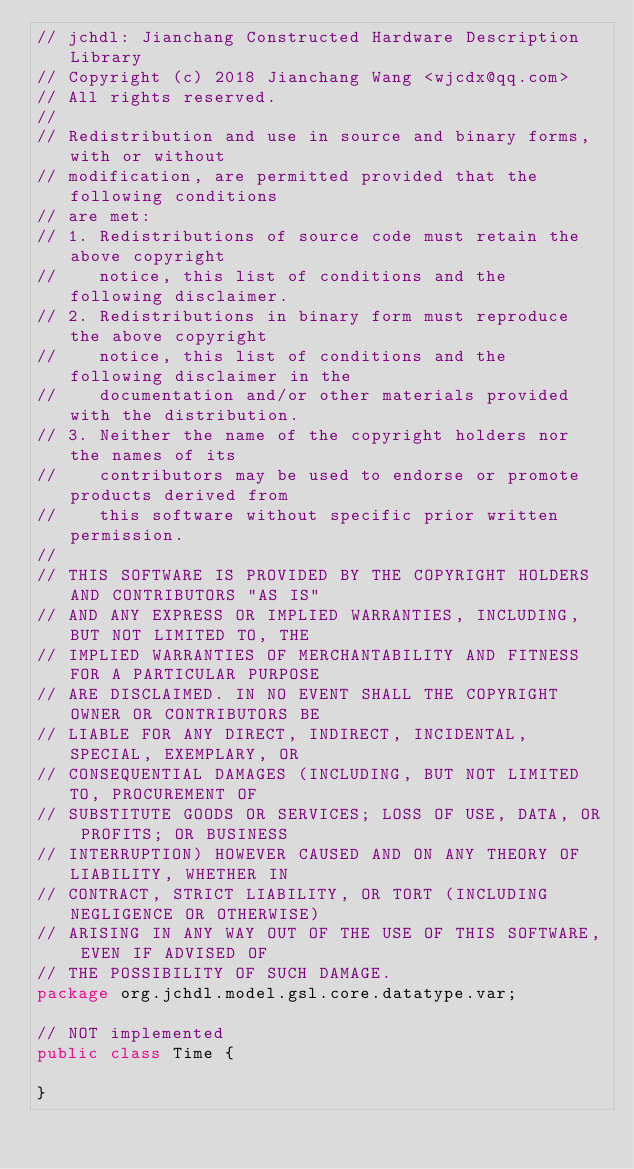<code> <loc_0><loc_0><loc_500><loc_500><_Java_>// jchdl: Jianchang Constructed Hardware Description Library
// Copyright (c) 2018 Jianchang Wang <wjcdx@qq.com>
// All rights reserved.
//
// Redistribution and use in source and binary forms, with or without
// modification, are permitted provided that the following conditions
// are met:
// 1. Redistributions of source code must retain the above copyright
//    notice, this list of conditions and the following disclaimer.
// 2. Redistributions in binary form must reproduce the above copyright
//    notice, this list of conditions and the following disclaimer in the
//    documentation and/or other materials provided with the distribution.
// 3. Neither the name of the copyright holders nor the names of its
//    contributors may be used to endorse or promote products derived from
//    this software without specific prior written permission.
//
// THIS SOFTWARE IS PROVIDED BY THE COPYRIGHT HOLDERS AND CONTRIBUTORS "AS IS"
// AND ANY EXPRESS OR IMPLIED WARRANTIES, INCLUDING, BUT NOT LIMITED TO, THE
// IMPLIED WARRANTIES OF MERCHANTABILITY AND FITNESS FOR A PARTICULAR PURPOSE
// ARE DISCLAIMED. IN NO EVENT SHALL THE COPYRIGHT OWNER OR CONTRIBUTORS BE
// LIABLE FOR ANY DIRECT, INDIRECT, INCIDENTAL, SPECIAL, EXEMPLARY, OR
// CONSEQUENTIAL DAMAGES (INCLUDING, BUT NOT LIMITED TO, PROCUREMENT OF
// SUBSTITUTE GOODS OR SERVICES; LOSS OF USE, DATA, OR PROFITS; OR BUSINESS
// INTERRUPTION) HOWEVER CAUSED AND ON ANY THEORY OF LIABILITY, WHETHER IN
// CONTRACT, STRICT LIABILITY, OR TORT (INCLUDING NEGLIGENCE OR OTHERWISE)
// ARISING IN ANY WAY OUT OF THE USE OF THIS SOFTWARE, EVEN IF ADVISED OF
// THE POSSIBILITY OF SUCH DAMAGE.
package org.jchdl.model.gsl.core.datatype.var;

// NOT implemented
public class Time {

}
</code> 